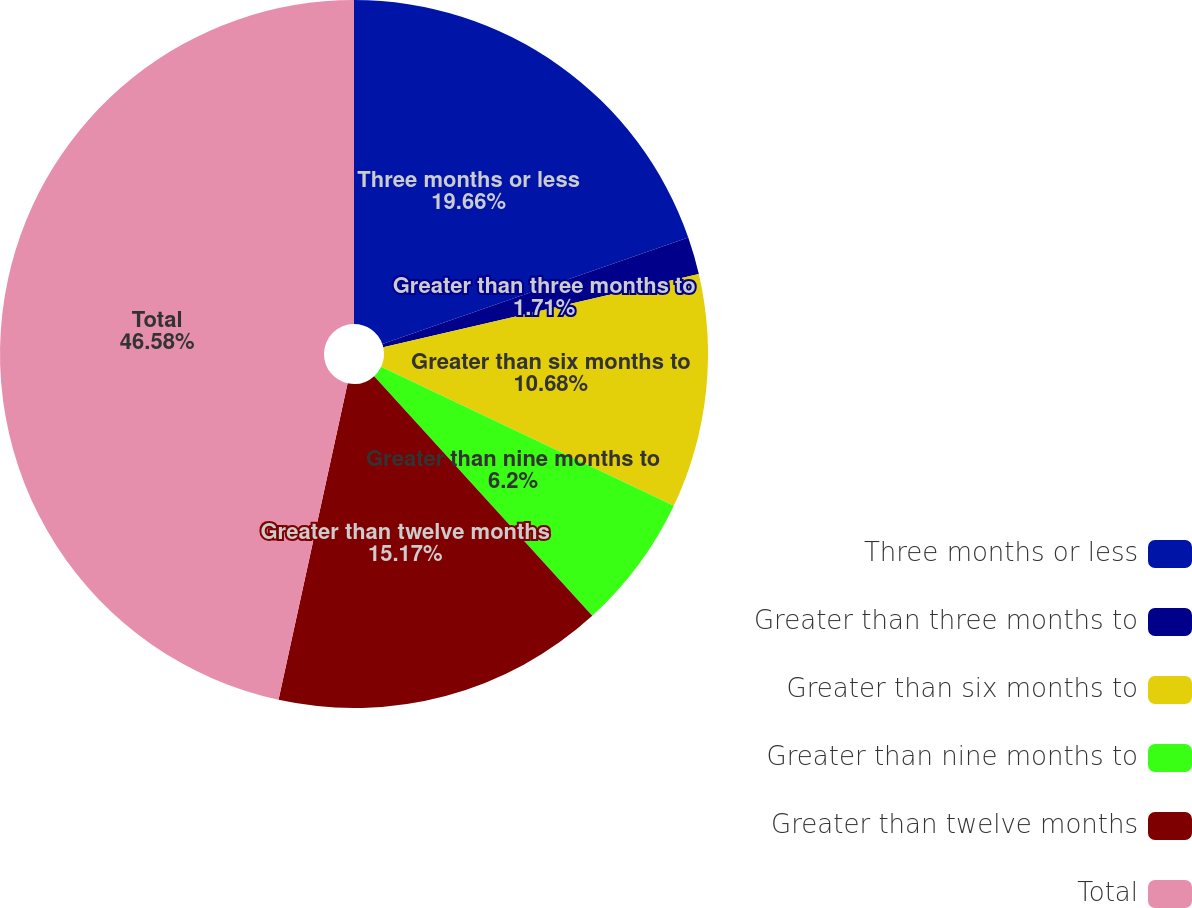Convert chart. <chart><loc_0><loc_0><loc_500><loc_500><pie_chart><fcel>Three months or less<fcel>Greater than three months to<fcel>Greater than six months to<fcel>Greater than nine months to<fcel>Greater than twelve months<fcel>Total<nl><fcel>19.66%<fcel>1.71%<fcel>10.68%<fcel>6.2%<fcel>15.17%<fcel>46.58%<nl></chart> 